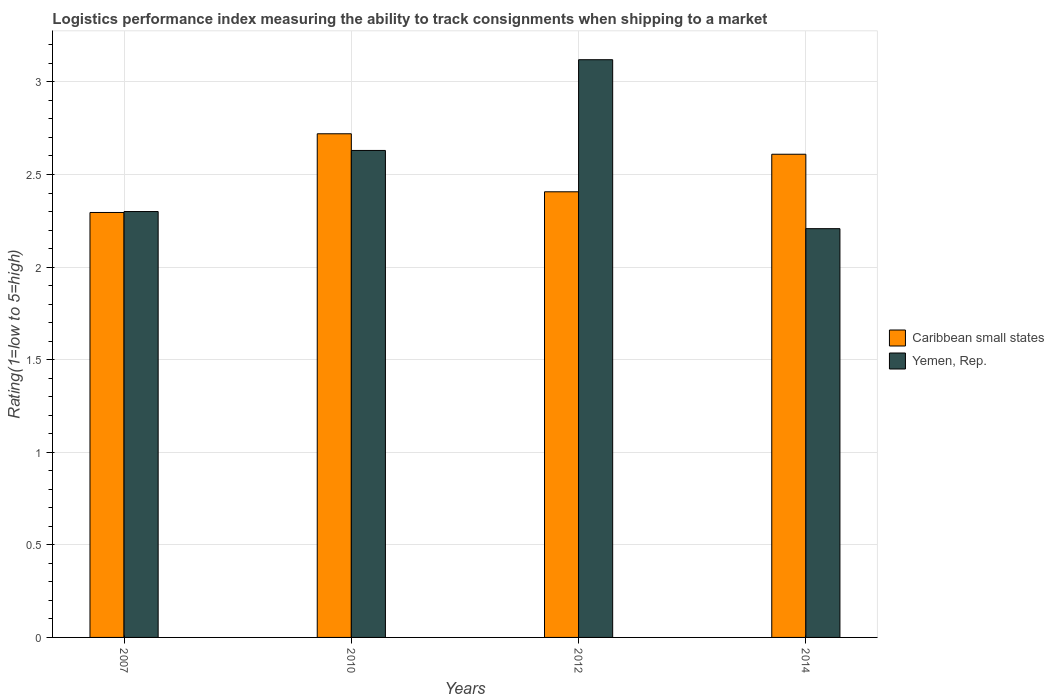How many different coloured bars are there?
Give a very brief answer. 2. Are the number of bars per tick equal to the number of legend labels?
Offer a terse response. Yes. Are the number of bars on each tick of the X-axis equal?
Make the answer very short. Yes. How many bars are there on the 2nd tick from the right?
Offer a terse response. 2. What is the label of the 4th group of bars from the left?
Provide a short and direct response. 2014. In how many cases, is the number of bars for a given year not equal to the number of legend labels?
Your answer should be very brief. 0. What is the Logistic performance index in Caribbean small states in 2014?
Make the answer very short. 2.61. Across all years, what is the maximum Logistic performance index in Caribbean small states?
Provide a short and direct response. 2.72. Across all years, what is the minimum Logistic performance index in Caribbean small states?
Ensure brevity in your answer.  2.29. What is the total Logistic performance index in Yemen, Rep. in the graph?
Your response must be concise. 10.26. What is the difference between the Logistic performance index in Yemen, Rep. in 2010 and that in 2014?
Give a very brief answer. 0.42. What is the difference between the Logistic performance index in Caribbean small states in 2010 and the Logistic performance index in Yemen, Rep. in 2014?
Your answer should be very brief. 0.51. What is the average Logistic performance index in Yemen, Rep. per year?
Provide a succinct answer. 2.56. In the year 2007, what is the difference between the Logistic performance index in Yemen, Rep. and Logistic performance index in Caribbean small states?
Provide a short and direct response. 0. In how many years, is the Logistic performance index in Caribbean small states greater than 2.5?
Provide a short and direct response. 2. What is the ratio of the Logistic performance index in Yemen, Rep. in 2007 to that in 2014?
Your answer should be compact. 1.04. Is the Logistic performance index in Caribbean small states in 2007 less than that in 2014?
Your answer should be compact. Yes. What is the difference between the highest and the second highest Logistic performance index in Yemen, Rep.?
Ensure brevity in your answer.  0.49. What is the difference between the highest and the lowest Logistic performance index in Caribbean small states?
Keep it short and to the point. 0.43. In how many years, is the Logistic performance index in Yemen, Rep. greater than the average Logistic performance index in Yemen, Rep. taken over all years?
Provide a succinct answer. 2. What does the 2nd bar from the left in 2014 represents?
Your answer should be compact. Yemen, Rep. What does the 1st bar from the right in 2010 represents?
Your answer should be compact. Yemen, Rep. Are all the bars in the graph horizontal?
Offer a terse response. No. What is the difference between two consecutive major ticks on the Y-axis?
Your answer should be compact. 0.5. Are the values on the major ticks of Y-axis written in scientific E-notation?
Provide a short and direct response. No. Where does the legend appear in the graph?
Provide a succinct answer. Center right. How are the legend labels stacked?
Your answer should be compact. Vertical. What is the title of the graph?
Give a very brief answer. Logistics performance index measuring the ability to track consignments when shipping to a market. Does "Middle income" appear as one of the legend labels in the graph?
Offer a very short reply. No. What is the label or title of the X-axis?
Your response must be concise. Years. What is the label or title of the Y-axis?
Ensure brevity in your answer.  Rating(1=low to 5=high). What is the Rating(1=low to 5=high) of Caribbean small states in 2007?
Offer a terse response. 2.29. What is the Rating(1=low to 5=high) in Yemen, Rep. in 2007?
Offer a very short reply. 2.3. What is the Rating(1=low to 5=high) in Caribbean small states in 2010?
Give a very brief answer. 2.72. What is the Rating(1=low to 5=high) in Yemen, Rep. in 2010?
Your answer should be compact. 2.63. What is the Rating(1=low to 5=high) of Caribbean small states in 2012?
Keep it short and to the point. 2.41. What is the Rating(1=low to 5=high) in Yemen, Rep. in 2012?
Your answer should be very brief. 3.12. What is the Rating(1=low to 5=high) in Caribbean small states in 2014?
Provide a succinct answer. 2.61. What is the Rating(1=low to 5=high) in Yemen, Rep. in 2014?
Give a very brief answer. 2.21. Across all years, what is the maximum Rating(1=low to 5=high) in Caribbean small states?
Make the answer very short. 2.72. Across all years, what is the maximum Rating(1=low to 5=high) of Yemen, Rep.?
Provide a succinct answer. 3.12. Across all years, what is the minimum Rating(1=low to 5=high) in Caribbean small states?
Make the answer very short. 2.29. Across all years, what is the minimum Rating(1=low to 5=high) in Yemen, Rep.?
Provide a short and direct response. 2.21. What is the total Rating(1=low to 5=high) of Caribbean small states in the graph?
Provide a short and direct response. 10.03. What is the total Rating(1=low to 5=high) of Yemen, Rep. in the graph?
Your answer should be very brief. 10.26. What is the difference between the Rating(1=low to 5=high) of Caribbean small states in 2007 and that in 2010?
Offer a very short reply. -0.42. What is the difference between the Rating(1=low to 5=high) in Yemen, Rep. in 2007 and that in 2010?
Your response must be concise. -0.33. What is the difference between the Rating(1=low to 5=high) of Caribbean small states in 2007 and that in 2012?
Provide a succinct answer. -0.11. What is the difference between the Rating(1=low to 5=high) of Yemen, Rep. in 2007 and that in 2012?
Offer a very short reply. -0.82. What is the difference between the Rating(1=low to 5=high) in Caribbean small states in 2007 and that in 2014?
Provide a short and direct response. -0.31. What is the difference between the Rating(1=low to 5=high) of Yemen, Rep. in 2007 and that in 2014?
Keep it short and to the point. 0.09. What is the difference between the Rating(1=low to 5=high) in Caribbean small states in 2010 and that in 2012?
Your answer should be very brief. 0.31. What is the difference between the Rating(1=low to 5=high) in Yemen, Rep. in 2010 and that in 2012?
Provide a short and direct response. -0.49. What is the difference between the Rating(1=low to 5=high) in Caribbean small states in 2010 and that in 2014?
Ensure brevity in your answer.  0.11. What is the difference between the Rating(1=low to 5=high) of Yemen, Rep. in 2010 and that in 2014?
Offer a very short reply. 0.42. What is the difference between the Rating(1=low to 5=high) in Caribbean small states in 2012 and that in 2014?
Ensure brevity in your answer.  -0.2. What is the difference between the Rating(1=low to 5=high) in Yemen, Rep. in 2012 and that in 2014?
Offer a very short reply. 0.91. What is the difference between the Rating(1=low to 5=high) in Caribbean small states in 2007 and the Rating(1=low to 5=high) in Yemen, Rep. in 2010?
Keep it short and to the point. -0.34. What is the difference between the Rating(1=low to 5=high) in Caribbean small states in 2007 and the Rating(1=low to 5=high) in Yemen, Rep. in 2012?
Keep it short and to the point. -0.82. What is the difference between the Rating(1=low to 5=high) of Caribbean small states in 2007 and the Rating(1=low to 5=high) of Yemen, Rep. in 2014?
Your answer should be compact. 0.09. What is the difference between the Rating(1=low to 5=high) in Caribbean small states in 2010 and the Rating(1=low to 5=high) in Yemen, Rep. in 2012?
Offer a very short reply. -0.4. What is the difference between the Rating(1=low to 5=high) of Caribbean small states in 2010 and the Rating(1=low to 5=high) of Yemen, Rep. in 2014?
Your answer should be compact. 0.51. What is the difference between the Rating(1=low to 5=high) in Caribbean small states in 2012 and the Rating(1=low to 5=high) in Yemen, Rep. in 2014?
Offer a very short reply. 0.2. What is the average Rating(1=low to 5=high) in Caribbean small states per year?
Ensure brevity in your answer.  2.51. What is the average Rating(1=low to 5=high) of Yemen, Rep. per year?
Offer a terse response. 2.56. In the year 2007, what is the difference between the Rating(1=low to 5=high) of Caribbean small states and Rating(1=low to 5=high) of Yemen, Rep.?
Your answer should be very brief. -0.01. In the year 2010, what is the difference between the Rating(1=low to 5=high) in Caribbean small states and Rating(1=low to 5=high) in Yemen, Rep.?
Ensure brevity in your answer.  0.09. In the year 2012, what is the difference between the Rating(1=low to 5=high) in Caribbean small states and Rating(1=low to 5=high) in Yemen, Rep.?
Your answer should be very brief. -0.71. In the year 2014, what is the difference between the Rating(1=low to 5=high) in Caribbean small states and Rating(1=low to 5=high) in Yemen, Rep.?
Offer a very short reply. 0.4. What is the ratio of the Rating(1=low to 5=high) in Caribbean small states in 2007 to that in 2010?
Your answer should be compact. 0.84. What is the ratio of the Rating(1=low to 5=high) in Yemen, Rep. in 2007 to that in 2010?
Your answer should be compact. 0.87. What is the ratio of the Rating(1=low to 5=high) in Caribbean small states in 2007 to that in 2012?
Your answer should be compact. 0.95. What is the ratio of the Rating(1=low to 5=high) in Yemen, Rep. in 2007 to that in 2012?
Offer a terse response. 0.74. What is the ratio of the Rating(1=low to 5=high) of Caribbean small states in 2007 to that in 2014?
Provide a short and direct response. 0.88. What is the ratio of the Rating(1=low to 5=high) of Yemen, Rep. in 2007 to that in 2014?
Provide a short and direct response. 1.04. What is the ratio of the Rating(1=low to 5=high) of Caribbean small states in 2010 to that in 2012?
Keep it short and to the point. 1.13. What is the ratio of the Rating(1=low to 5=high) in Yemen, Rep. in 2010 to that in 2012?
Ensure brevity in your answer.  0.84. What is the ratio of the Rating(1=low to 5=high) of Caribbean small states in 2010 to that in 2014?
Provide a short and direct response. 1.04. What is the ratio of the Rating(1=low to 5=high) of Yemen, Rep. in 2010 to that in 2014?
Make the answer very short. 1.19. What is the ratio of the Rating(1=low to 5=high) of Caribbean small states in 2012 to that in 2014?
Your answer should be compact. 0.92. What is the ratio of the Rating(1=low to 5=high) of Yemen, Rep. in 2012 to that in 2014?
Your answer should be very brief. 1.41. What is the difference between the highest and the second highest Rating(1=low to 5=high) in Caribbean small states?
Your response must be concise. 0.11. What is the difference between the highest and the second highest Rating(1=low to 5=high) in Yemen, Rep.?
Make the answer very short. 0.49. What is the difference between the highest and the lowest Rating(1=low to 5=high) of Caribbean small states?
Your answer should be compact. 0.42. What is the difference between the highest and the lowest Rating(1=low to 5=high) in Yemen, Rep.?
Keep it short and to the point. 0.91. 